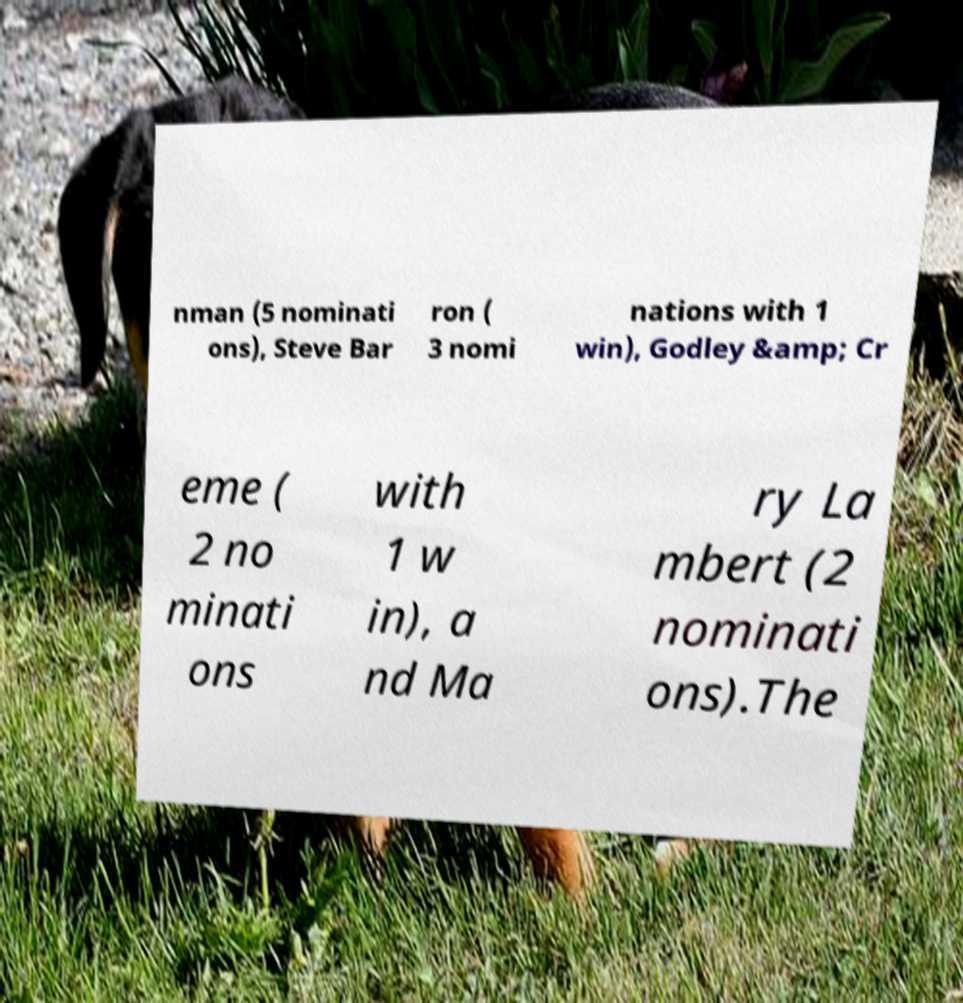Could you assist in decoding the text presented in this image and type it out clearly? nman (5 nominati ons), Steve Bar ron ( 3 nomi nations with 1 win), Godley &amp; Cr eme ( 2 no minati ons with 1 w in), a nd Ma ry La mbert (2 nominati ons).The 